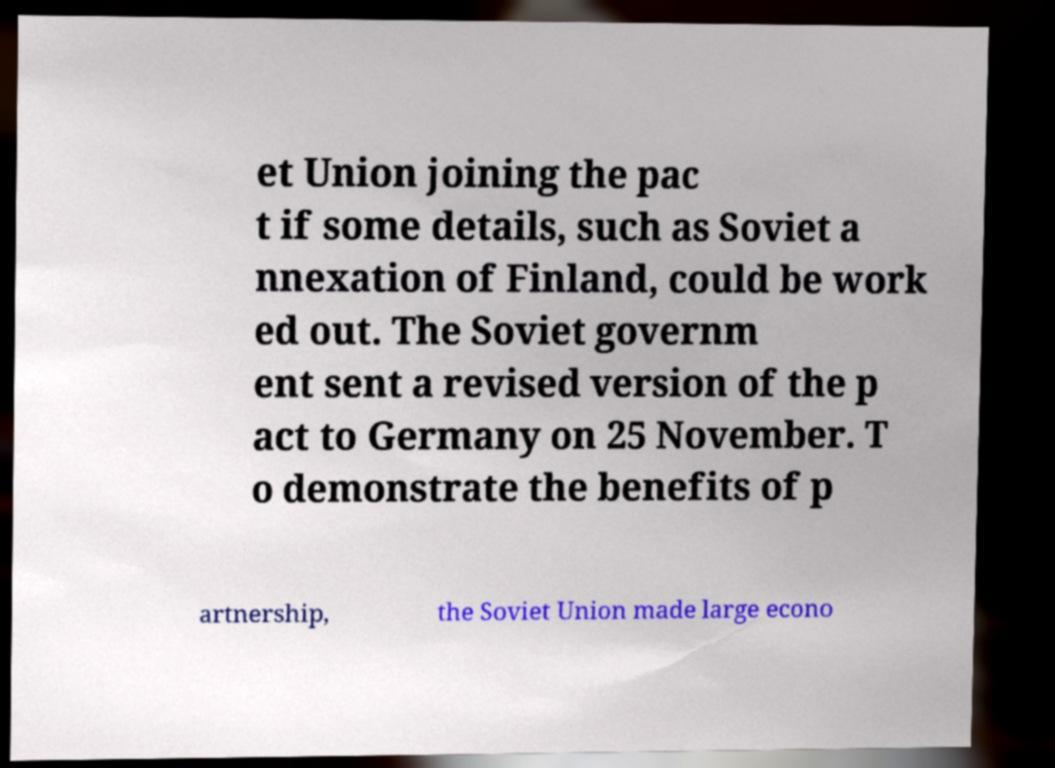There's text embedded in this image that I need extracted. Can you transcribe it verbatim? et Union joining the pac t if some details, such as Soviet a nnexation of Finland, could be work ed out. The Soviet governm ent sent a revised version of the p act to Germany on 25 November. T o demonstrate the benefits of p artnership, the Soviet Union made large econo 